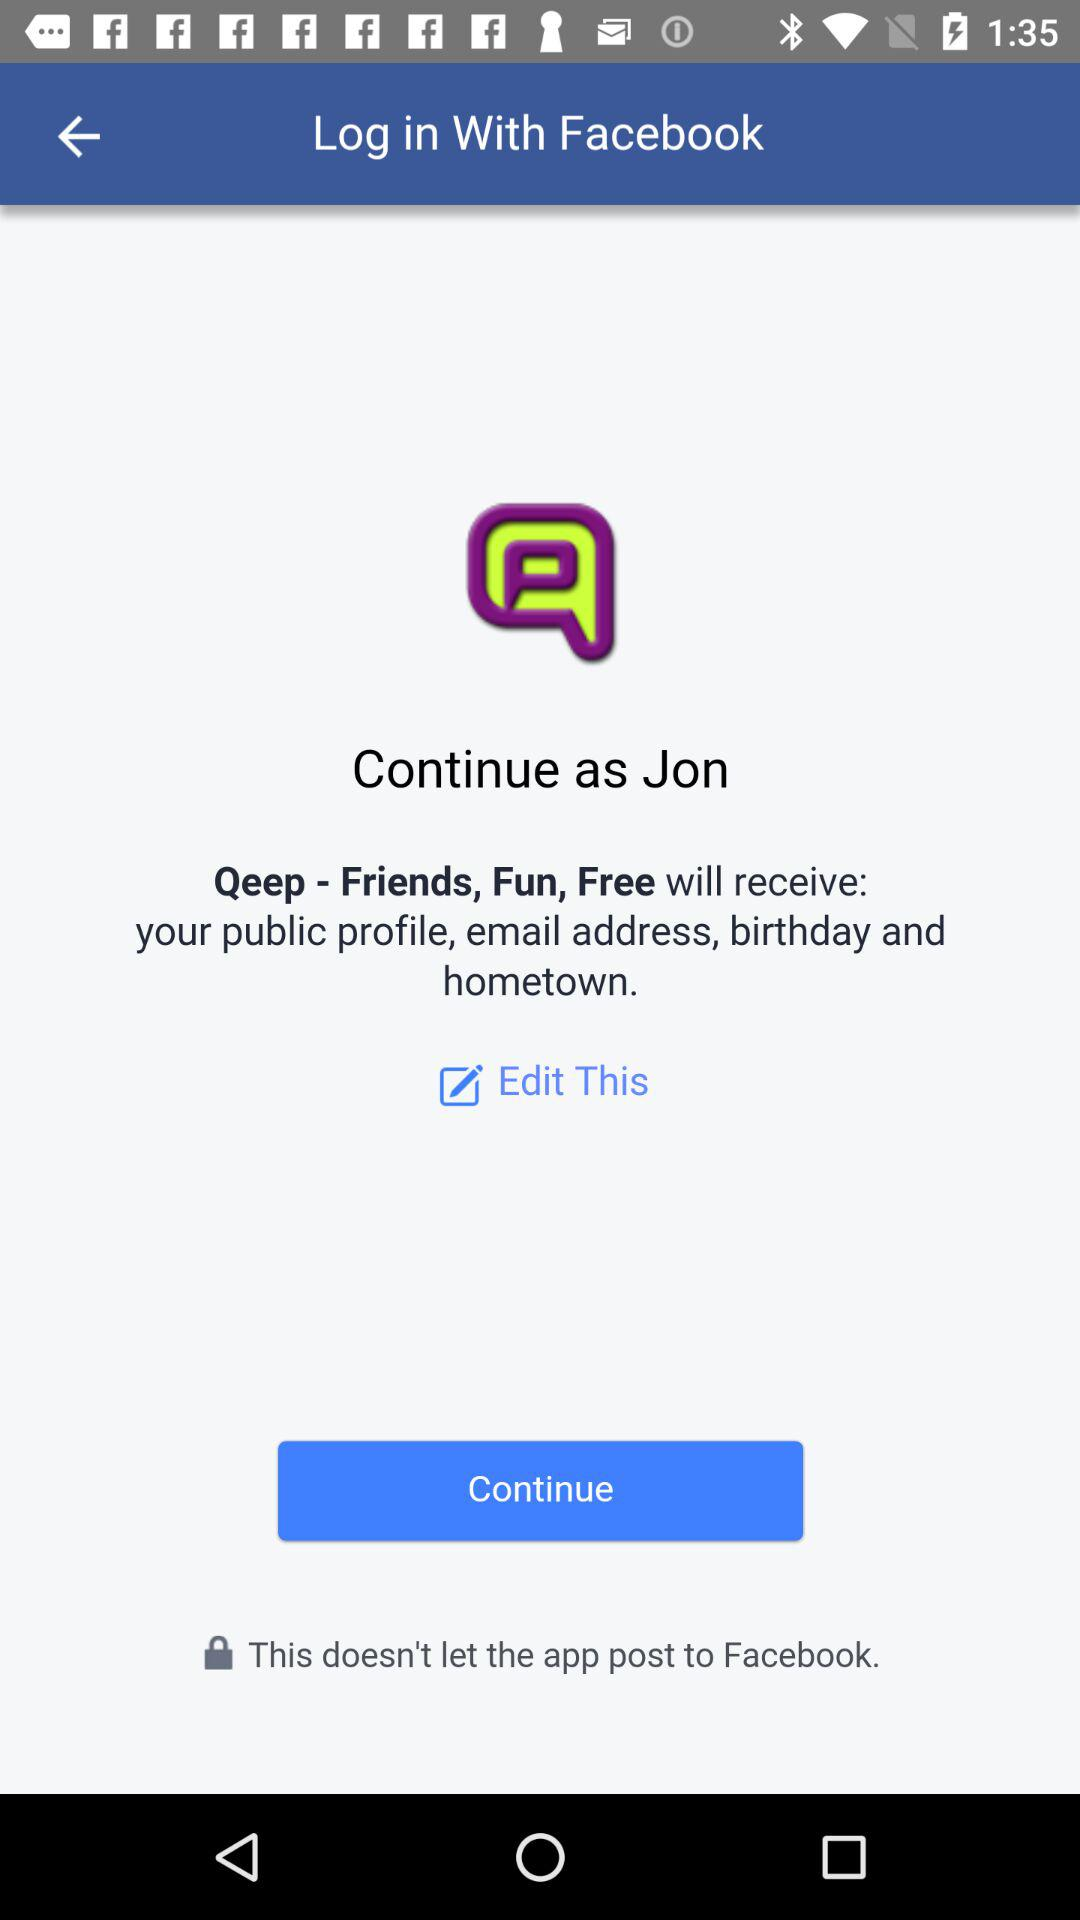What application is asking for permission? The application that is asking for permission is "Qeep - Friends, Fun, Free". 